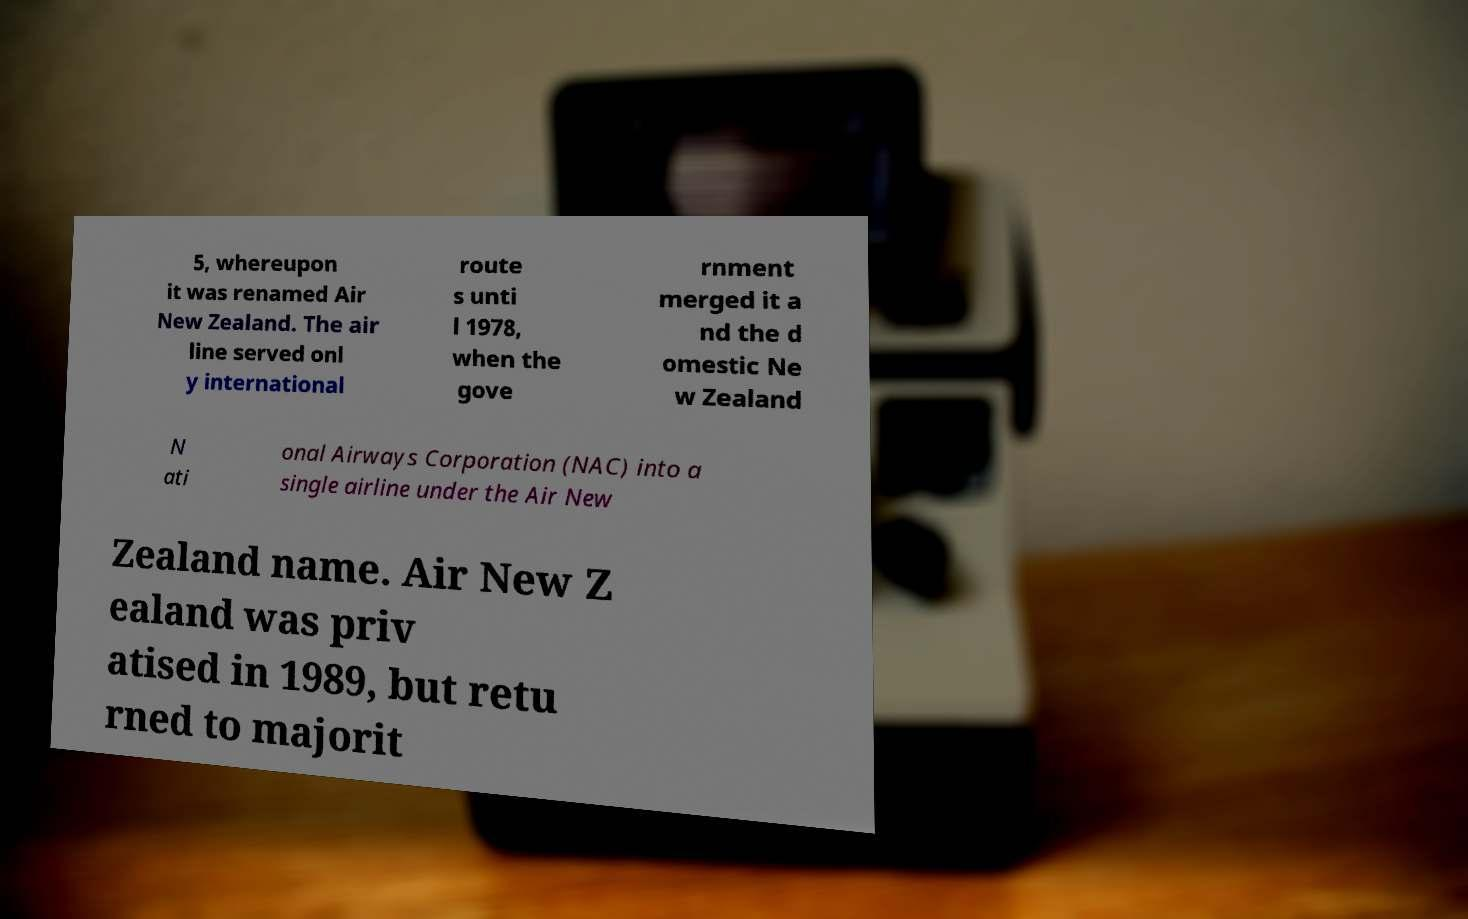Can you accurately transcribe the text from the provided image for me? 5, whereupon it was renamed Air New Zealand. The air line served onl y international route s unti l 1978, when the gove rnment merged it a nd the d omestic Ne w Zealand N ati onal Airways Corporation (NAC) into a single airline under the Air New Zealand name. Air New Z ealand was priv atised in 1989, but retu rned to majorit 